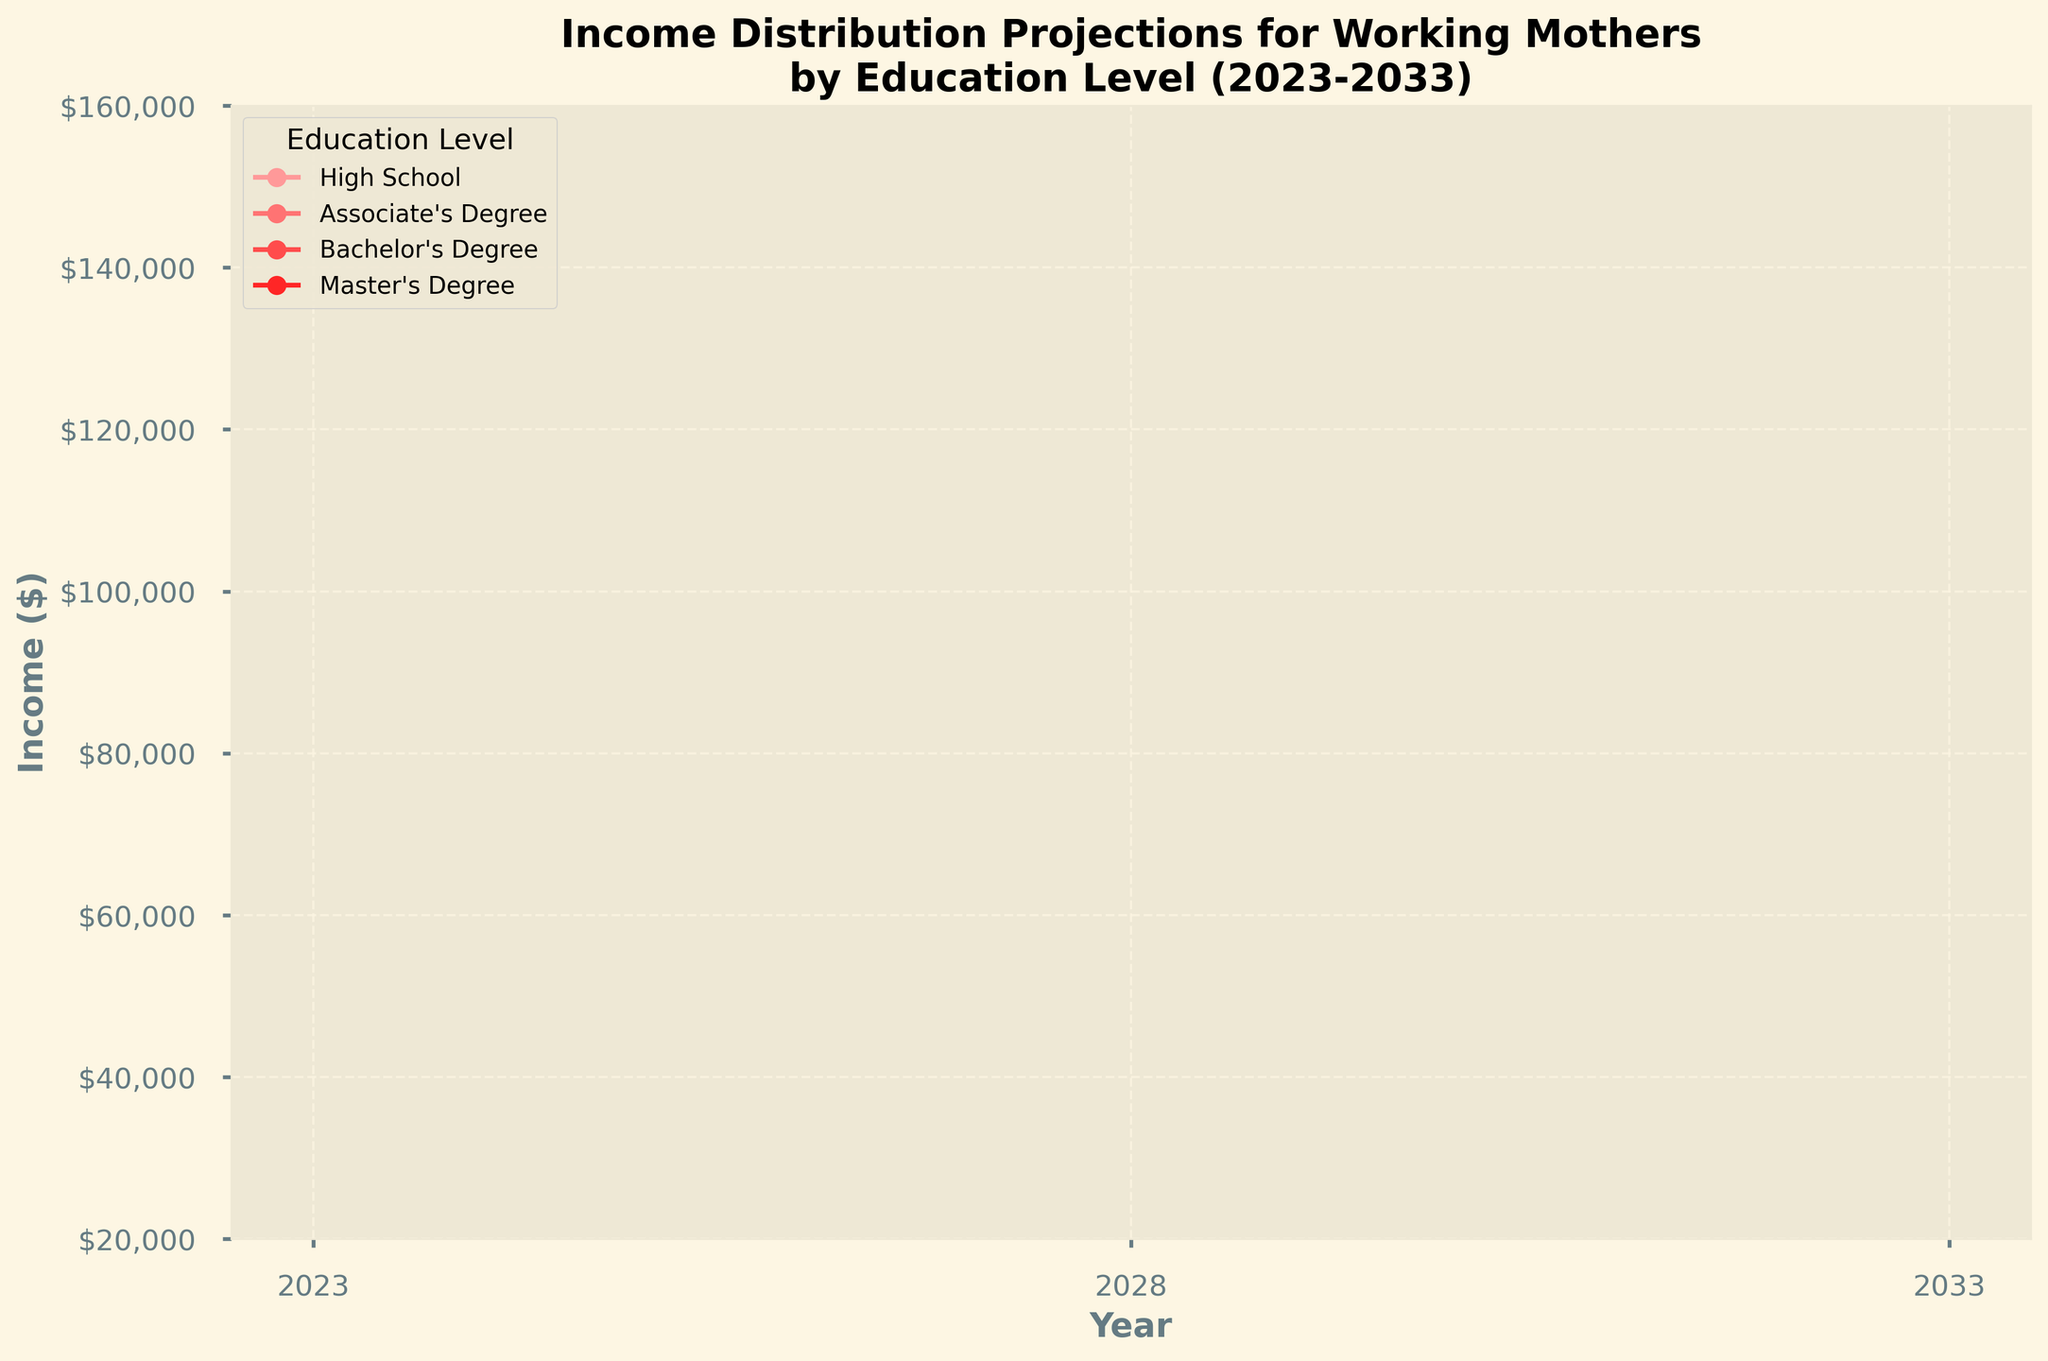What's the median income projection for working mothers with a Bachelor's Degree in 2028? Locate the year 2028 on the x-axis, then find the median value for the Bachelor's Degree line at that point.
Answer: $69,000 What is the range between the 10th and 90th percentile incomes for working mothers with an Associate's Degree in 2023? Look for the lowest (10th percentile) and highest (90th percentile) projections for Associate's Degree in 2023 and subtract the lower value from the higher value.
Answer: $29,000 Which education level is projected to have the highest median income in 2033? Find the median income values for all education levels in 2033 and compare them to identify the highest one.
Answer: Master's Degree How much is the median income for working mothers with a High School diploma expected to increase from 2023 to 2033? Locate the median income values for 2023 and 2033 for High School, then subtract the value for 2023 from that for 2033.
Answer: $7,000 Between 2023 and 2028, which education level is expected to see the greatest change in the 75th percentile income? Identify the 75th percentile income for each education level in 2023 and 2028, calculate the change for each, and compare them to find the greatest change.
Answer: Master's Degree What is the difference in the 25th percentile income between working mothers with a Bachelor's Degree and those with an Associate's Degree in 2028? Locate the 25th percentile income values for Bachelor's and Associate’s Degrees in 2028 and find the difference by subtracting the Associate's value from the Bachelor's value.
Answer: $14,000 In which year is the income distribution for working mothers with a Master's Degree expected to span the widest range between the 10th and 90th percentiles? For each year, calculate the range (90th percentile - 10th percentile) for Master’s Degree and compare these ranges to find the widest one.
Answer: 2033 Compare the median income projection in 2033 for working mothers with an Associate's Degree to the 75th percentile income projection for those with a High School diploma. Which is higher? Find the median value for Associate's Degree and the 75th percentile value for High School in 2033 and compare them to see which is higher.
Answer: Associate's Degree Are the income projections for working mothers with a Bachelor's Degree always higher across all percentiles compared to those with only a High School diploma? For each percentile (10th, 25th, median, 75th, 90th) and each year, compare the projections of Bachelor's Degree and High School to verify if Bachelor's Degree is consistently higher.
Answer: Yes Which education level shows the smallest growth in median income from 2023 to 2028? Calculate the median income growth for each education level between 2023 and 2028 and compare them to find the smallest growth.
Answer: High School 